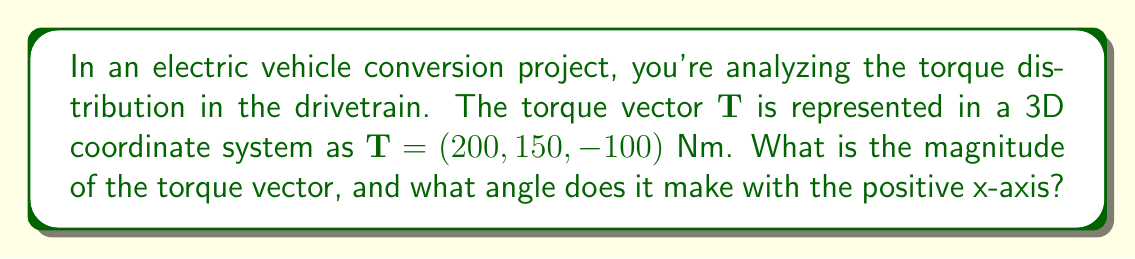Show me your answer to this math problem. To solve this problem, we'll follow these steps:

1. Calculate the magnitude of the torque vector:
   The magnitude of a 3D vector $(x, y, z)$ is given by $\sqrt{x^2 + y^2 + z^2}$.
   
   $$|\mathbf{T}| = \sqrt{200^2 + 150^2 + (-100)^2}$$
   $$|\mathbf{T}| = \sqrt{40000 + 22500 + 10000}$$
   $$|\mathbf{T}| = \sqrt{72500} \approx 269.26 \text{ Nm}$$

2. Calculate the angle with the positive x-axis:
   The angle $\theta$ between a vector and the positive x-axis is given by:
   $$\theta = \arccos\left(\frac{x}{|\mathbf{T}|}\right)$$
   
   Where $x$ is the x-component of the vector and $|\mathbf{T}|$ is its magnitude.

   $$\theta = \arccos\left(\frac{200}{269.26}\right)$$
   $$\theta \approx 0.6435 \text{ radians}$$

3. Convert radians to degrees:
   $$\theta \approx 0.6435 \times \frac{180}{\pi} \approx 36.87°$$

[asy]
import geometry;

size(200);
draw((-1,0)--(3,0),Arrow);
draw((0,-1)--(0,3),Arrow);
draw((0,0)--(2,1.5),Arrow);
label("x", (3,0), E);
label("y", (0,3), N);
label("T", (2,1.5), NE);
draw(arc((0,0),0.5,0,36.87),Arrow);
label("θ", (0.3,0.2), NE);
[/asy]
Answer: $|\mathbf{T}| \approx 269.26 \text{ Nm}, \theta \approx 36.87°$ 